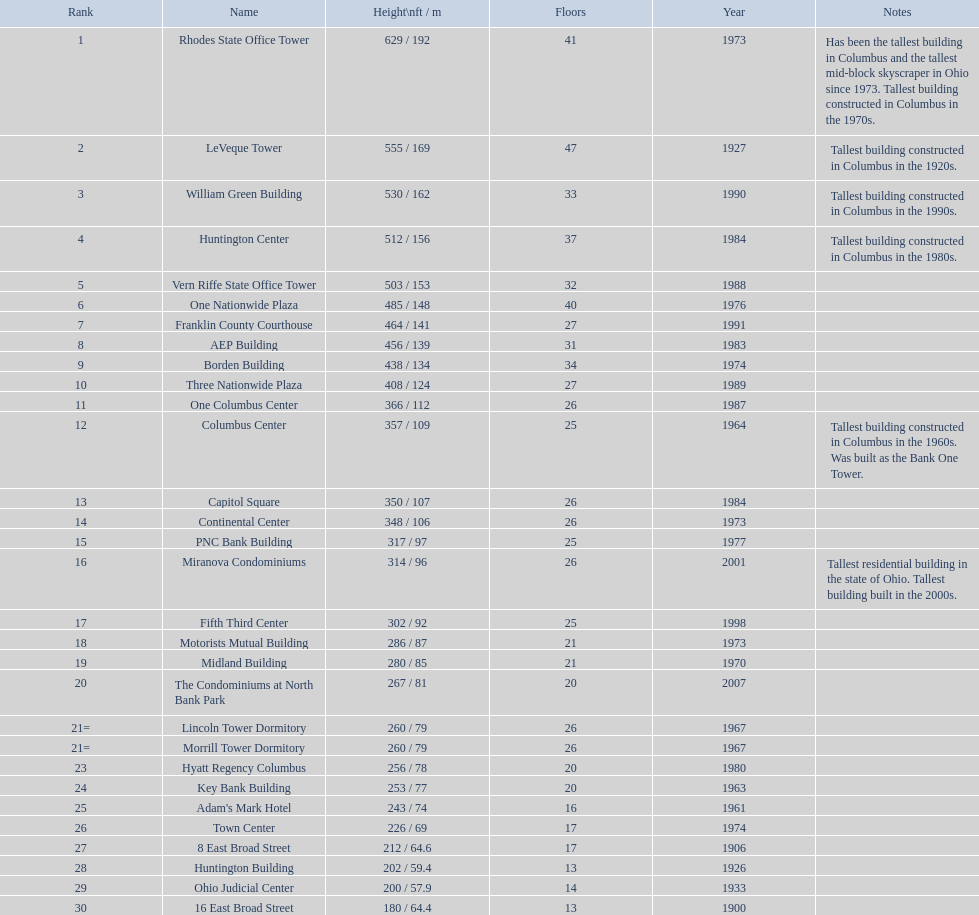What buildings stand taller than 500 feet in height? Rhodes State Office Tower, LeVeque Tower, William Green Building, Huntington Center, Vern Riffe State Office Tower. 